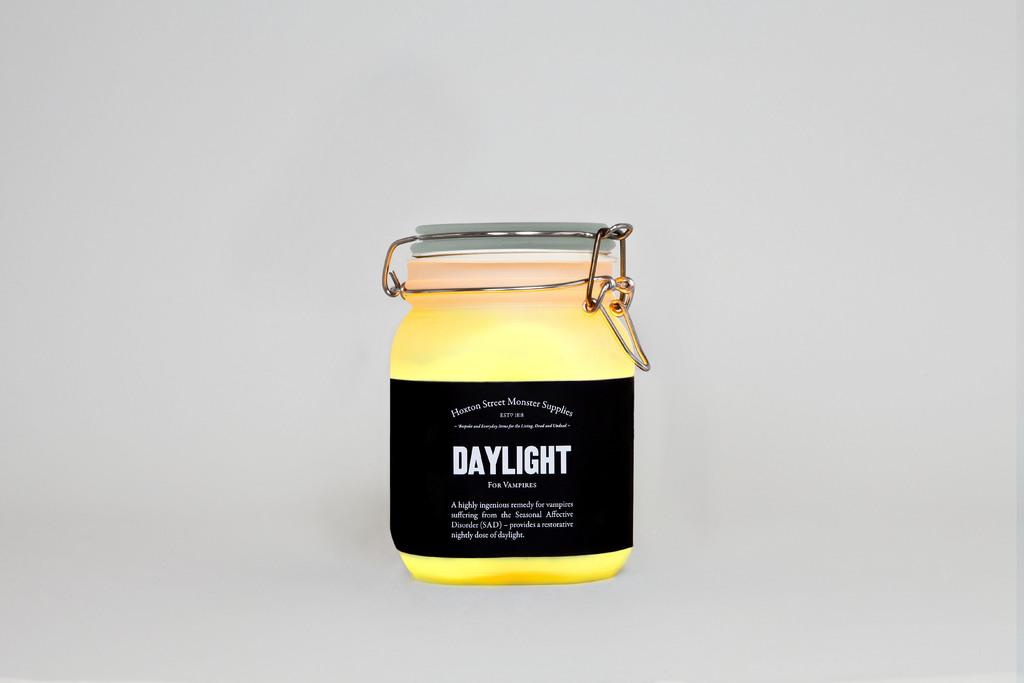<image>
Present a compact description of the photo's key features. A jar of yellow stuff called daylight is for vampires. 